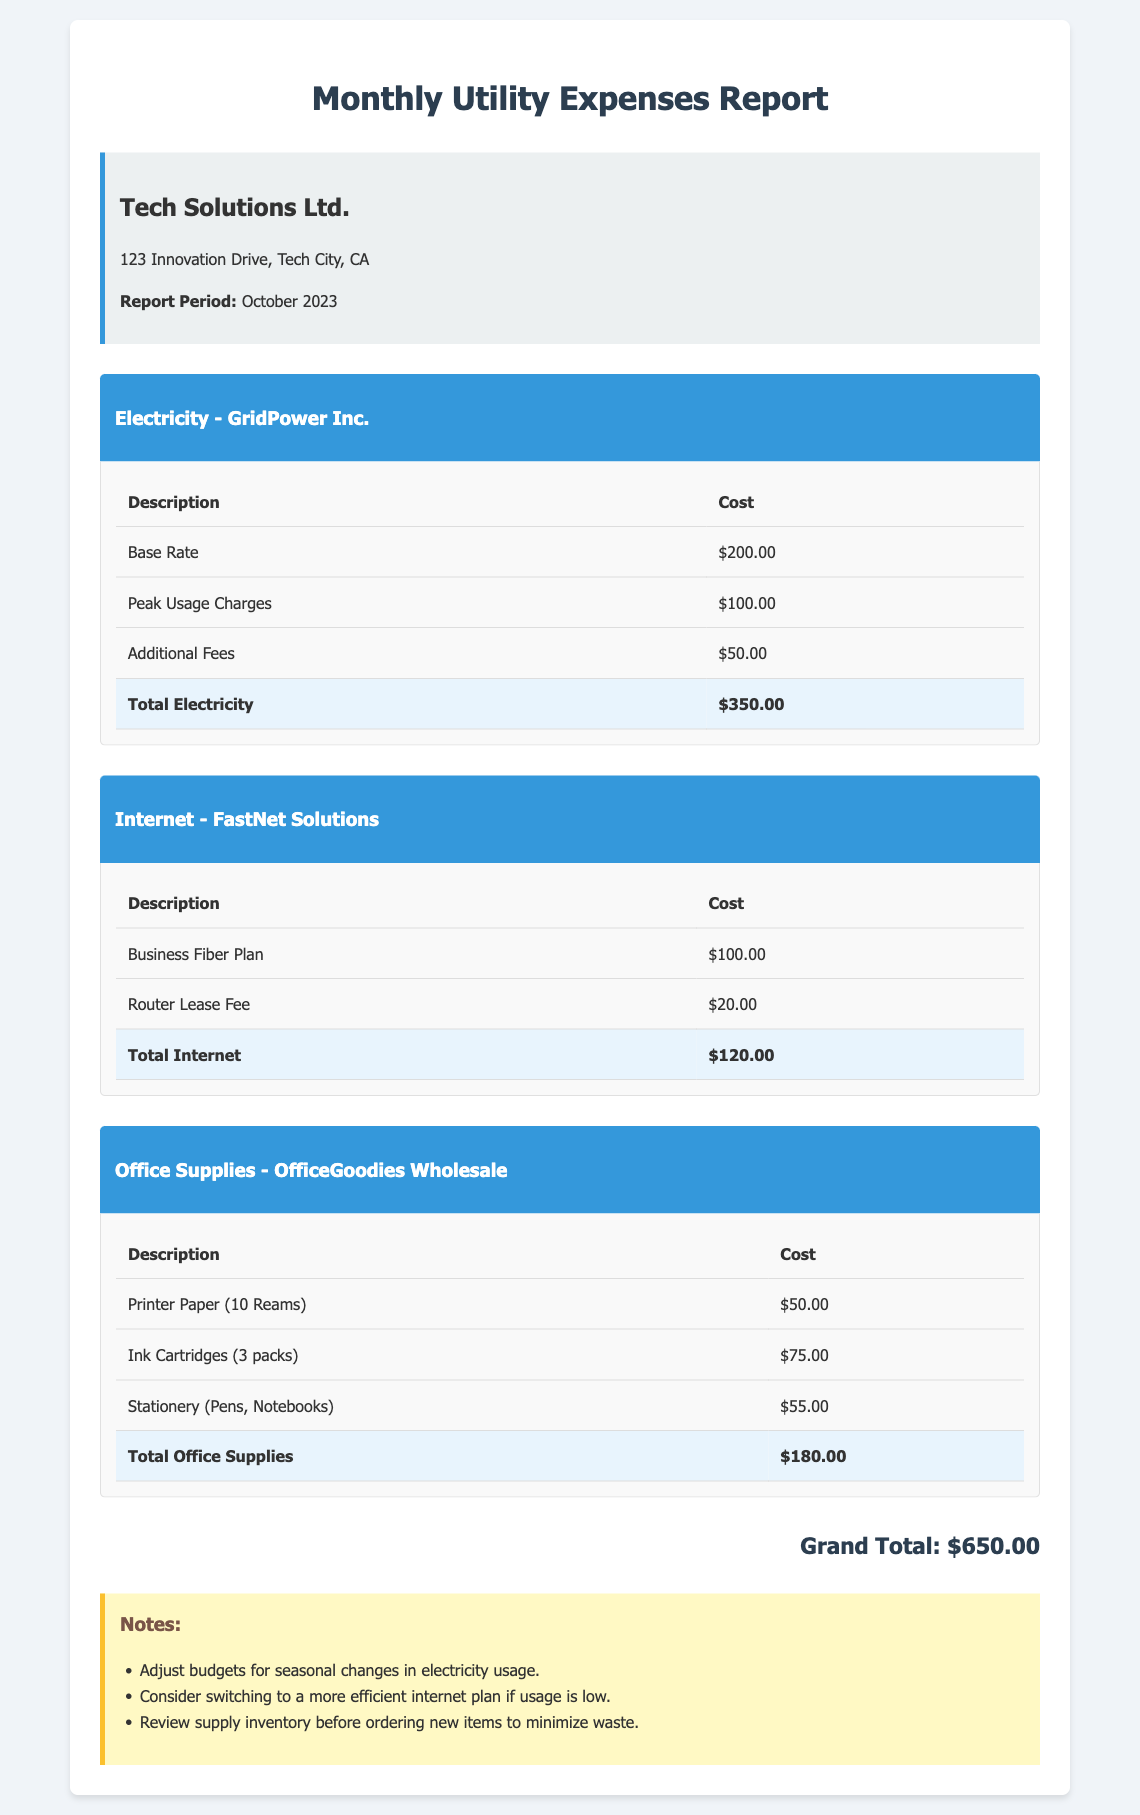What is the total cost for electricity? The total cost for electricity is specified in the document as the sum of its components: Base Rate, Peak Usage Charges, and Additional Fees, which equals $350.00.
Answer: $350.00 What is the cost for the Business Fiber Plan? The document lists the cost for the Business Fiber Plan under Internet expenses, which is $100.00.
Answer: $100.00 How much did the office supplies cost in total? The total cost for office supplies is provided in the document as the sum of Printer Paper, Ink Cartridges, and Stationery, which totals $180.00.
Answer: $180.00 What is the grand total for all utility expenses? The grand total is calculated by summing the totals for electricity, internet, and office supplies, reported in the document as $650.00.
Answer: $650.00 Which company provides the internet service? The internet service provider is named in the document as FastNet Solutions.
Answer: FastNet Solutions What additional fees are included in the electricity cost? Additional fees related to electricity are mentioned in the document as a component of the electricity expenses, specifically listed as $50.00.
Answer: $50.00 How many reams of printer paper were purchased? The document states that 10 reams of printer paper were bought under office supplies.
Answer: 10 Reams What is recommended to minimize waste in office supplies? The document suggests reviewing supply inventory before ordering new items to minimize waste.
Answer: Review supply inventory 